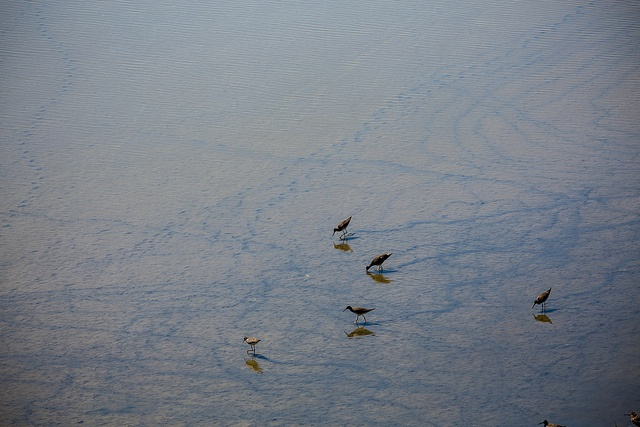Describe the objects in this image and their specific colors. I can see bird in gray, black, and darkgray tones, bird in gray, black, and maroon tones, bird in gray, black, and tan tones, bird in gray, black, maroon, and darkgray tones, and bird in gray, black, and maroon tones in this image. 